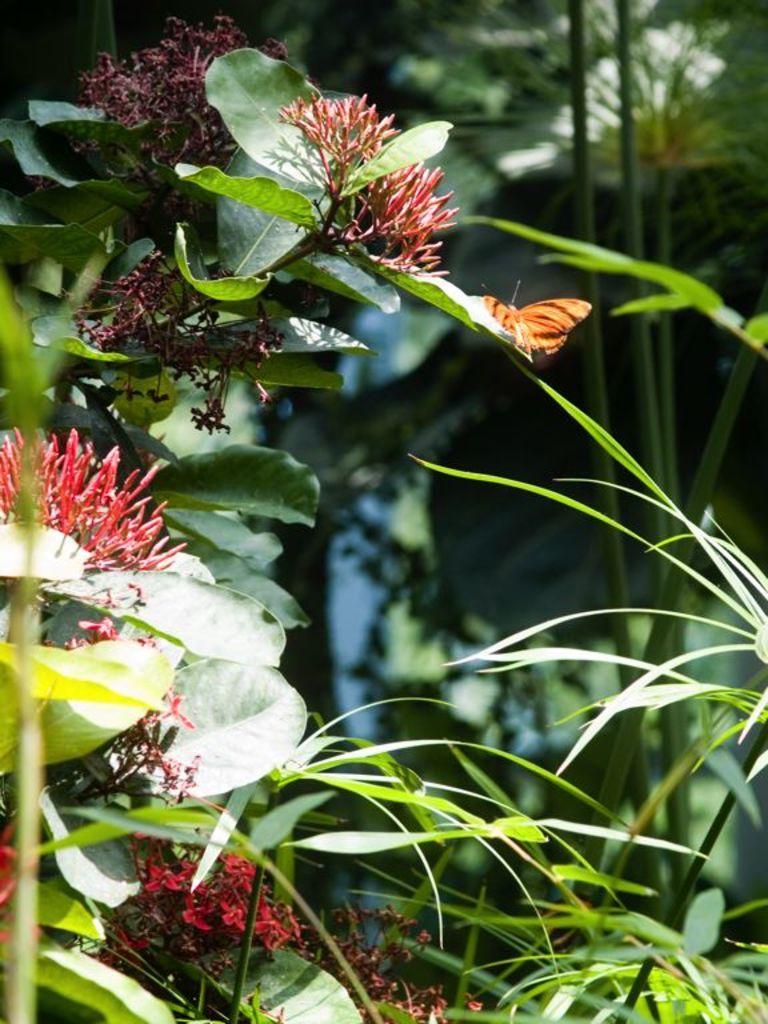In one or two sentences, can you explain what this image depicts? In this image I can see few plants along with flowers and leaves. There is a butterfly on a leaf. In the background few plants and trees are visible. 